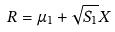Convert formula to latex. <formula><loc_0><loc_0><loc_500><loc_500>R = \mu _ { 1 } + \sqrt { S _ { 1 } } X</formula> 